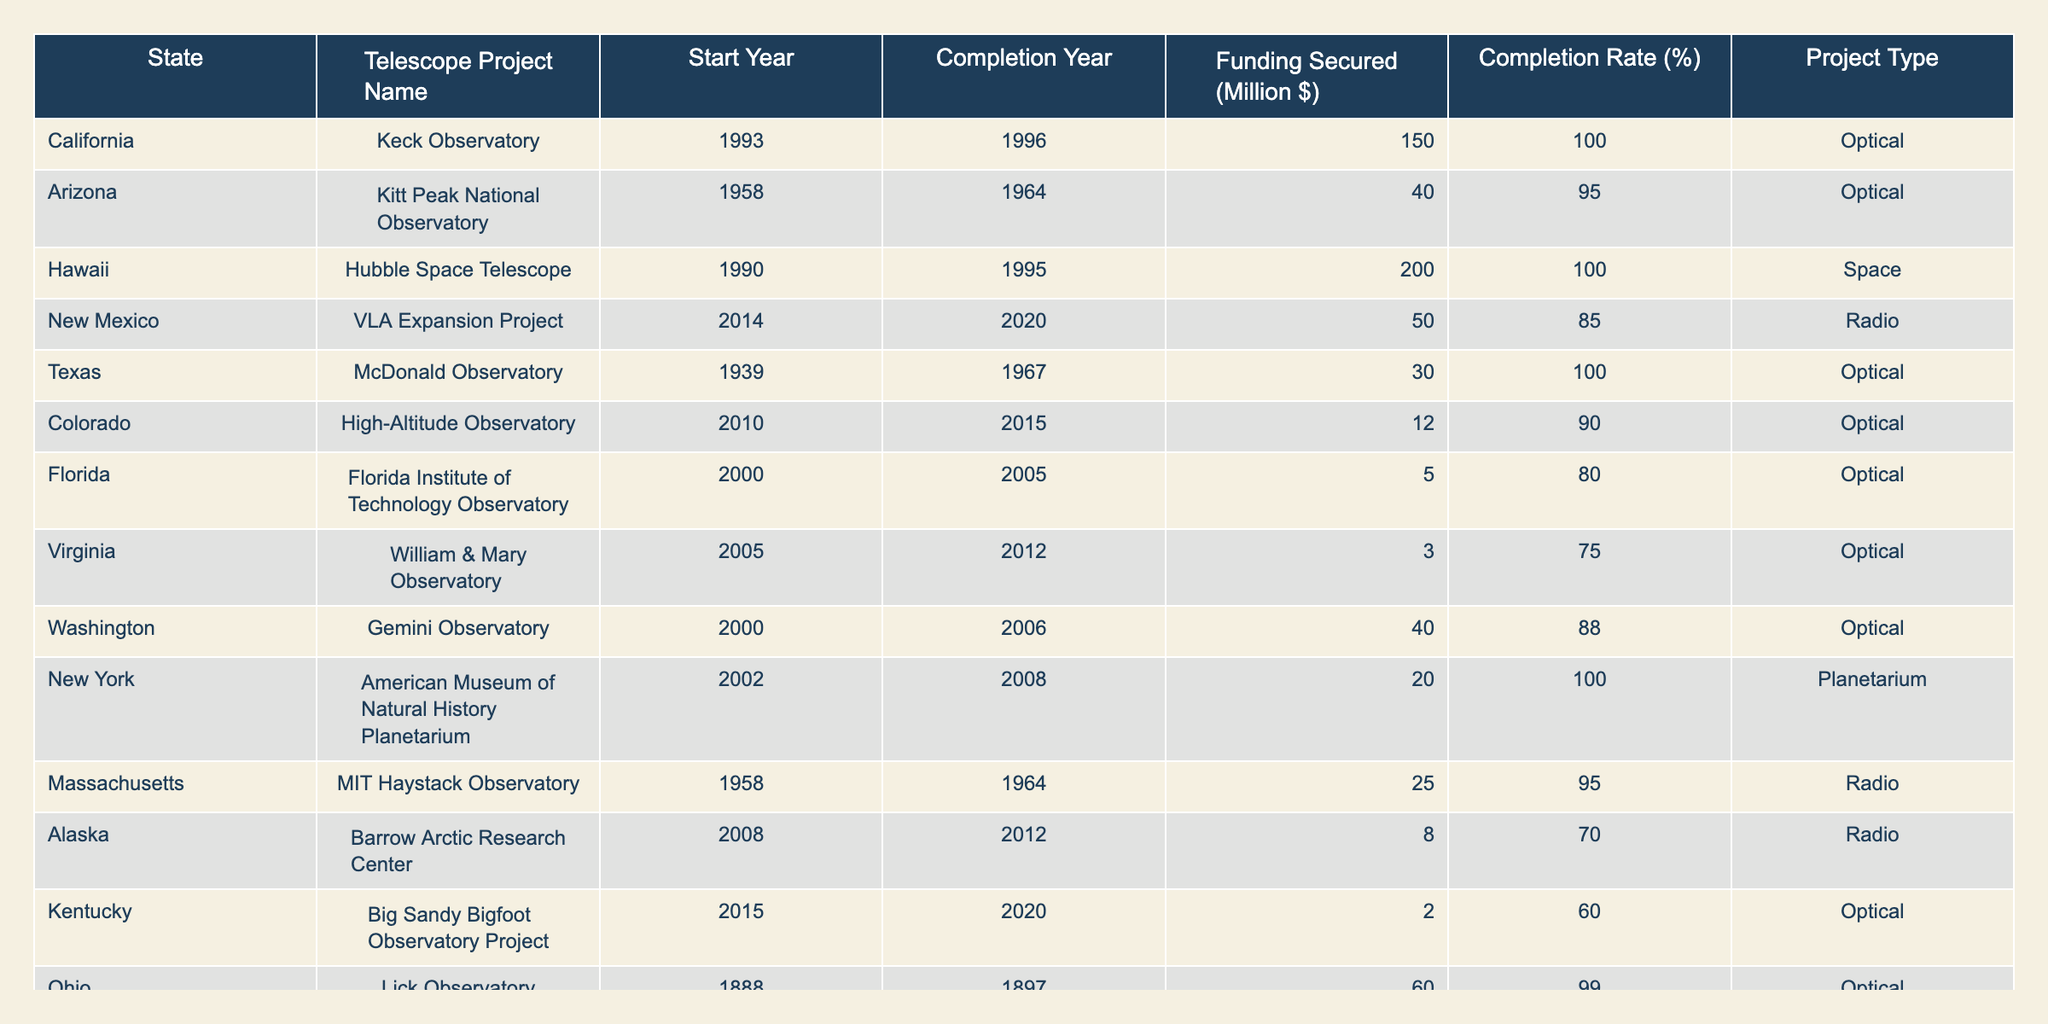What is the completion rate of the Hubble Space Telescope project? The completion rate for the Hubble Space Telescope project listed in Hawaii is 100%.
Answer: 100% Which state has the least amount of funding secured for a telescope project? The Kentucky telescope project has the least funding secured at 2 million dollars.
Answer: 2 million dollars What is the average completion rate of all telescope projects in this table? To find the average, sum all completion rates (100 + 95 + 100 + 85 + 100 + 90 + 80 + 75 + 88 + 100 + 95 + 70 + 60 + 99 + 80) = 1340. There are 15 projects, so the average is 1340 / 15 ≈ 89.33%.
Answer: Approximately 89.33% Did any telescope project in Texas have a completion rate below 100%? No, the McDonald Observatory in Texas achieved a completion rate of 100%.
Answer: No Which telescope project has the highest funding-to-completion rate ratio? To find the highest ratio, calculate funding divided by completion rate for each project. For example, Hubble has 200 / 100 = 2. The minimum ratio found is for Kentucky: 2 / 60 = 0.033. By comparing all ratios, Hubble has the highest ratio of 2.
Answer: Hubble Space Telescope How many more years did the VLA Expansion Project take to complete compared to the Florida Institute of Technology Observatory? The VLA Expansion Project took 6 years (2014-2020) and the Florida Institute took 5 years (2000-2005), so it took 1 more year than Florida.
Answer: 1 year What proportion of projects are classified as Optical type? There are 10 Optical projects out of 15 total projects, so the proportion is 10 / 15 = 2/3 or approximately 66.67%.
Answer: Approximately 66.67% Identify the states that have completed projects funded over 100 million dollars. The states with projects funded over 100 million dollars are California (Keck Observatory) and Hawaii (Hubble Space Telescope).
Answer: California and Hawaii What is the total funding secured for telescope projects listed in Ohio and Oregon combined? The funding secured for Ohio (Lick Observatory) is 60 million and for Oregon (Mount Hood Observatory) is 10 million, giving a total of 60 + 10 = 70 million dollars.
Answer: 70 million dollars What is the state with the highest completion rate for radio telescope projects? The only states with radio telescope projects are New Mexico (85%) and Massachusetts (95%). Massachusetts has the highest completion rate.
Answer: Massachusetts 